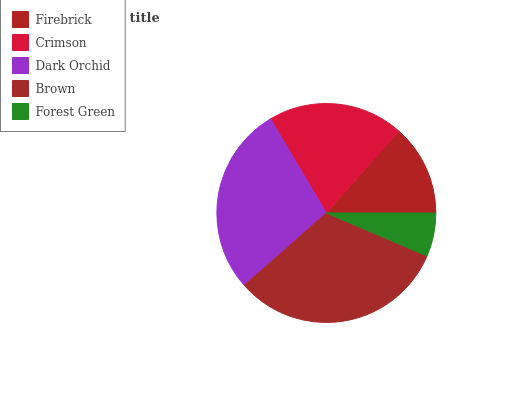Is Forest Green the minimum?
Answer yes or no. Yes. Is Brown the maximum?
Answer yes or no. Yes. Is Crimson the minimum?
Answer yes or no. No. Is Crimson the maximum?
Answer yes or no. No. Is Crimson greater than Firebrick?
Answer yes or no. Yes. Is Firebrick less than Crimson?
Answer yes or no. Yes. Is Firebrick greater than Crimson?
Answer yes or no. No. Is Crimson less than Firebrick?
Answer yes or no. No. Is Crimson the high median?
Answer yes or no. Yes. Is Crimson the low median?
Answer yes or no. Yes. Is Forest Green the high median?
Answer yes or no. No. Is Brown the low median?
Answer yes or no. No. 